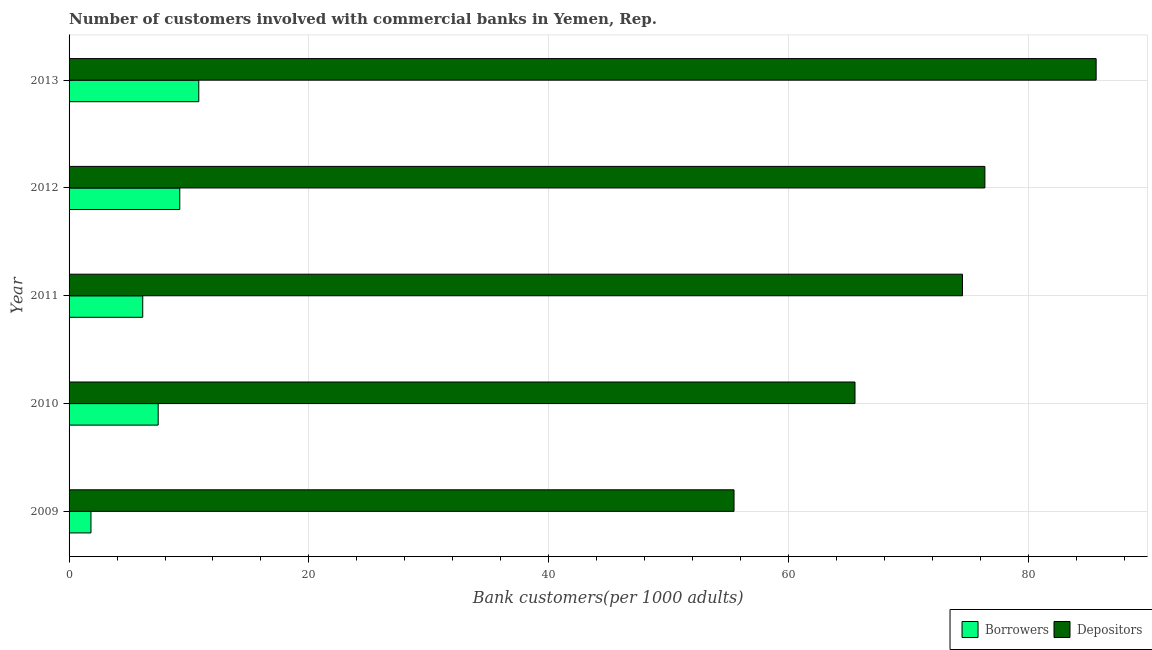How many different coloured bars are there?
Offer a terse response. 2. How many groups of bars are there?
Provide a short and direct response. 5. What is the label of the 5th group of bars from the top?
Your answer should be very brief. 2009. What is the number of borrowers in 2009?
Provide a short and direct response. 1.83. Across all years, what is the maximum number of depositors?
Offer a very short reply. 85.65. Across all years, what is the minimum number of borrowers?
Provide a succinct answer. 1.83. In which year was the number of depositors maximum?
Provide a short and direct response. 2013. What is the total number of depositors in the graph?
Provide a short and direct response. 357.52. What is the difference between the number of borrowers in 2009 and that in 2013?
Offer a very short reply. -8.99. What is the difference between the number of borrowers in 2010 and the number of depositors in 2009?
Ensure brevity in your answer.  -48.02. What is the average number of depositors per year?
Ensure brevity in your answer.  71.5. In the year 2009, what is the difference between the number of depositors and number of borrowers?
Your answer should be compact. 53.63. What is the ratio of the number of borrowers in 2010 to that in 2011?
Provide a succinct answer. 1.21. Is the number of borrowers in 2010 less than that in 2012?
Keep it short and to the point. Yes. What is the difference between the highest and the second highest number of depositors?
Your response must be concise. 9.28. What is the difference between the highest and the lowest number of depositors?
Your response must be concise. 30.2. In how many years, is the number of depositors greater than the average number of depositors taken over all years?
Offer a very short reply. 3. Is the sum of the number of borrowers in 2010 and 2013 greater than the maximum number of depositors across all years?
Keep it short and to the point. No. What does the 2nd bar from the top in 2011 represents?
Keep it short and to the point. Borrowers. What does the 2nd bar from the bottom in 2010 represents?
Ensure brevity in your answer.  Depositors. Are all the bars in the graph horizontal?
Offer a very short reply. Yes. How many years are there in the graph?
Make the answer very short. 5. Are the values on the major ticks of X-axis written in scientific E-notation?
Your answer should be very brief. No. Does the graph contain any zero values?
Your answer should be compact. No. Does the graph contain grids?
Offer a terse response. Yes. Where does the legend appear in the graph?
Keep it short and to the point. Bottom right. How many legend labels are there?
Ensure brevity in your answer.  2. How are the legend labels stacked?
Your answer should be very brief. Horizontal. What is the title of the graph?
Provide a short and direct response. Number of customers involved with commercial banks in Yemen, Rep. Does "Personal remittances" appear as one of the legend labels in the graph?
Your answer should be very brief. No. What is the label or title of the X-axis?
Make the answer very short. Bank customers(per 1000 adults). What is the label or title of the Y-axis?
Make the answer very short. Year. What is the Bank customers(per 1000 adults) of Borrowers in 2009?
Give a very brief answer. 1.83. What is the Bank customers(per 1000 adults) in Depositors in 2009?
Provide a short and direct response. 55.45. What is the Bank customers(per 1000 adults) of Borrowers in 2010?
Your answer should be compact. 7.43. What is the Bank customers(per 1000 adults) in Depositors in 2010?
Provide a succinct answer. 65.54. What is the Bank customers(per 1000 adults) of Borrowers in 2011?
Keep it short and to the point. 6.14. What is the Bank customers(per 1000 adults) in Depositors in 2011?
Provide a succinct answer. 74.5. What is the Bank customers(per 1000 adults) in Borrowers in 2012?
Ensure brevity in your answer.  9.23. What is the Bank customers(per 1000 adults) in Depositors in 2012?
Your answer should be very brief. 76.37. What is the Bank customers(per 1000 adults) in Borrowers in 2013?
Make the answer very short. 10.82. What is the Bank customers(per 1000 adults) in Depositors in 2013?
Keep it short and to the point. 85.65. Across all years, what is the maximum Bank customers(per 1000 adults) of Borrowers?
Your answer should be very brief. 10.82. Across all years, what is the maximum Bank customers(per 1000 adults) in Depositors?
Provide a succinct answer. 85.65. Across all years, what is the minimum Bank customers(per 1000 adults) in Borrowers?
Your response must be concise. 1.83. Across all years, what is the minimum Bank customers(per 1000 adults) in Depositors?
Offer a terse response. 55.45. What is the total Bank customers(per 1000 adults) of Borrowers in the graph?
Provide a succinct answer. 35.45. What is the total Bank customers(per 1000 adults) in Depositors in the graph?
Your answer should be compact. 357.52. What is the difference between the Bank customers(per 1000 adults) of Borrowers in 2009 and that in 2010?
Provide a succinct answer. -5.6. What is the difference between the Bank customers(per 1000 adults) of Depositors in 2009 and that in 2010?
Your answer should be very brief. -10.09. What is the difference between the Bank customers(per 1000 adults) of Borrowers in 2009 and that in 2011?
Offer a very short reply. -4.32. What is the difference between the Bank customers(per 1000 adults) in Depositors in 2009 and that in 2011?
Offer a very short reply. -19.05. What is the difference between the Bank customers(per 1000 adults) in Borrowers in 2009 and that in 2012?
Your response must be concise. -7.41. What is the difference between the Bank customers(per 1000 adults) in Depositors in 2009 and that in 2012?
Offer a very short reply. -20.92. What is the difference between the Bank customers(per 1000 adults) of Borrowers in 2009 and that in 2013?
Ensure brevity in your answer.  -8.99. What is the difference between the Bank customers(per 1000 adults) in Depositors in 2009 and that in 2013?
Your answer should be compact. -30.2. What is the difference between the Bank customers(per 1000 adults) of Borrowers in 2010 and that in 2011?
Keep it short and to the point. 1.29. What is the difference between the Bank customers(per 1000 adults) of Depositors in 2010 and that in 2011?
Give a very brief answer. -8.96. What is the difference between the Bank customers(per 1000 adults) in Borrowers in 2010 and that in 2012?
Give a very brief answer. -1.8. What is the difference between the Bank customers(per 1000 adults) of Depositors in 2010 and that in 2012?
Provide a succinct answer. -10.83. What is the difference between the Bank customers(per 1000 adults) of Borrowers in 2010 and that in 2013?
Your response must be concise. -3.39. What is the difference between the Bank customers(per 1000 adults) of Depositors in 2010 and that in 2013?
Your answer should be compact. -20.11. What is the difference between the Bank customers(per 1000 adults) of Borrowers in 2011 and that in 2012?
Make the answer very short. -3.09. What is the difference between the Bank customers(per 1000 adults) in Depositors in 2011 and that in 2012?
Your response must be concise. -1.87. What is the difference between the Bank customers(per 1000 adults) in Borrowers in 2011 and that in 2013?
Provide a succinct answer. -4.67. What is the difference between the Bank customers(per 1000 adults) of Depositors in 2011 and that in 2013?
Provide a short and direct response. -11.15. What is the difference between the Bank customers(per 1000 adults) of Borrowers in 2012 and that in 2013?
Provide a succinct answer. -1.58. What is the difference between the Bank customers(per 1000 adults) of Depositors in 2012 and that in 2013?
Your answer should be very brief. -9.28. What is the difference between the Bank customers(per 1000 adults) of Borrowers in 2009 and the Bank customers(per 1000 adults) of Depositors in 2010?
Offer a very short reply. -63.71. What is the difference between the Bank customers(per 1000 adults) in Borrowers in 2009 and the Bank customers(per 1000 adults) in Depositors in 2011?
Provide a succinct answer. -72.68. What is the difference between the Bank customers(per 1000 adults) in Borrowers in 2009 and the Bank customers(per 1000 adults) in Depositors in 2012?
Make the answer very short. -74.55. What is the difference between the Bank customers(per 1000 adults) of Borrowers in 2009 and the Bank customers(per 1000 adults) of Depositors in 2013?
Ensure brevity in your answer.  -83.82. What is the difference between the Bank customers(per 1000 adults) of Borrowers in 2010 and the Bank customers(per 1000 adults) of Depositors in 2011?
Ensure brevity in your answer.  -67.07. What is the difference between the Bank customers(per 1000 adults) in Borrowers in 2010 and the Bank customers(per 1000 adults) in Depositors in 2012?
Offer a very short reply. -68.94. What is the difference between the Bank customers(per 1000 adults) in Borrowers in 2010 and the Bank customers(per 1000 adults) in Depositors in 2013?
Offer a terse response. -78.22. What is the difference between the Bank customers(per 1000 adults) of Borrowers in 2011 and the Bank customers(per 1000 adults) of Depositors in 2012?
Make the answer very short. -70.23. What is the difference between the Bank customers(per 1000 adults) of Borrowers in 2011 and the Bank customers(per 1000 adults) of Depositors in 2013?
Make the answer very short. -79.51. What is the difference between the Bank customers(per 1000 adults) of Borrowers in 2012 and the Bank customers(per 1000 adults) of Depositors in 2013?
Your response must be concise. -76.42. What is the average Bank customers(per 1000 adults) in Borrowers per year?
Make the answer very short. 7.09. What is the average Bank customers(per 1000 adults) of Depositors per year?
Offer a very short reply. 71.5. In the year 2009, what is the difference between the Bank customers(per 1000 adults) in Borrowers and Bank customers(per 1000 adults) in Depositors?
Your response must be concise. -53.63. In the year 2010, what is the difference between the Bank customers(per 1000 adults) in Borrowers and Bank customers(per 1000 adults) in Depositors?
Provide a succinct answer. -58.11. In the year 2011, what is the difference between the Bank customers(per 1000 adults) of Borrowers and Bank customers(per 1000 adults) of Depositors?
Offer a very short reply. -68.36. In the year 2012, what is the difference between the Bank customers(per 1000 adults) of Borrowers and Bank customers(per 1000 adults) of Depositors?
Make the answer very short. -67.14. In the year 2013, what is the difference between the Bank customers(per 1000 adults) of Borrowers and Bank customers(per 1000 adults) of Depositors?
Your answer should be compact. -74.83. What is the ratio of the Bank customers(per 1000 adults) of Borrowers in 2009 to that in 2010?
Ensure brevity in your answer.  0.25. What is the ratio of the Bank customers(per 1000 adults) in Depositors in 2009 to that in 2010?
Provide a succinct answer. 0.85. What is the ratio of the Bank customers(per 1000 adults) in Borrowers in 2009 to that in 2011?
Provide a short and direct response. 0.3. What is the ratio of the Bank customers(per 1000 adults) in Depositors in 2009 to that in 2011?
Give a very brief answer. 0.74. What is the ratio of the Bank customers(per 1000 adults) in Borrowers in 2009 to that in 2012?
Provide a short and direct response. 0.2. What is the ratio of the Bank customers(per 1000 adults) in Depositors in 2009 to that in 2012?
Your answer should be very brief. 0.73. What is the ratio of the Bank customers(per 1000 adults) in Borrowers in 2009 to that in 2013?
Your answer should be compact. 0.17. What is the ratio of the Bank customers(per 1000 adults) in Depositors in 2009 to that in 2013?
Provide a short and direct response. 0.65. What is the ratio of the Bank customers(per 1000 adults) of Borrowers in 2010 to that in 2011?
Give a very brief answer. 1.21. What is the ratio of the Bank customers(per 1000 adults) of Depositors in 2010 to that in 2011?
Give a very brief answer. 0.88. What is the ratio of the Bank customers(per 1000 adults) in Borrowers in 2010 to that in 2012?
Your response must be concise. 0.8. What is the ratio of the Bank customers(per 1000 adults) of Depositors in 2010 to that in 2012?
Your answer should be compact. 0.86. What is the ratio of the Bank customers(per 1000 adults) of Borrowers in 2010 to that in 2013?
Your answer should be compact. 0.69. What is the ratio of the Bank customers(per 1000 adults) of Depositors in 2010 to that in 2013?
Offer a terse response. 0.77. What is the ratio of the Bank customers(per 1000 adults) in Borrowers in 2011 to that in 2012?
Provide a succinct answer. 0.67. What is the ratio of the Bank customers(per 1000 adults) of Depositors in 2011 to that in 2012?
Your response must be concise. 0.98. What is the ratio of the Bank customers(per 1000 adults) of Borrowers in 2011 to that in 2013?
Your answer should be compact. 0.57. What is the ratio of the Bank customers(per 1000 adults) of Depositors in 2011 to that in 2013?
Ensure brevity in your answer.  0.87. What is the ratio of the Bank customers(per 1000 adults) in Borrowers in 2012 to that in 2013?
Your answer should be very brief. 0.85. What is the ratio of the Bank customers(per 1000 adults) in Depositors in 2012 to that in 2013?
Give a very brief answer. 0.89. What is the difference between the highest and the second highest Bank customers(per 1000 adults) of Borrowers?
Keep it short and to the point. 1.58. What is the difference between the highest and the second highest Bank customers(per 1000 adults) of Depositors?
Keep it short and to the point. 9.28. What is the difference between the highest and the lowest Bank customers(per 1000 adults) in Borrowers?
Offer a terse response. 8.99. What is the difference between the highest and the lowest Bank customers(per 1000 adults) in Depositors?
Offer a very short reply. 30.2. 